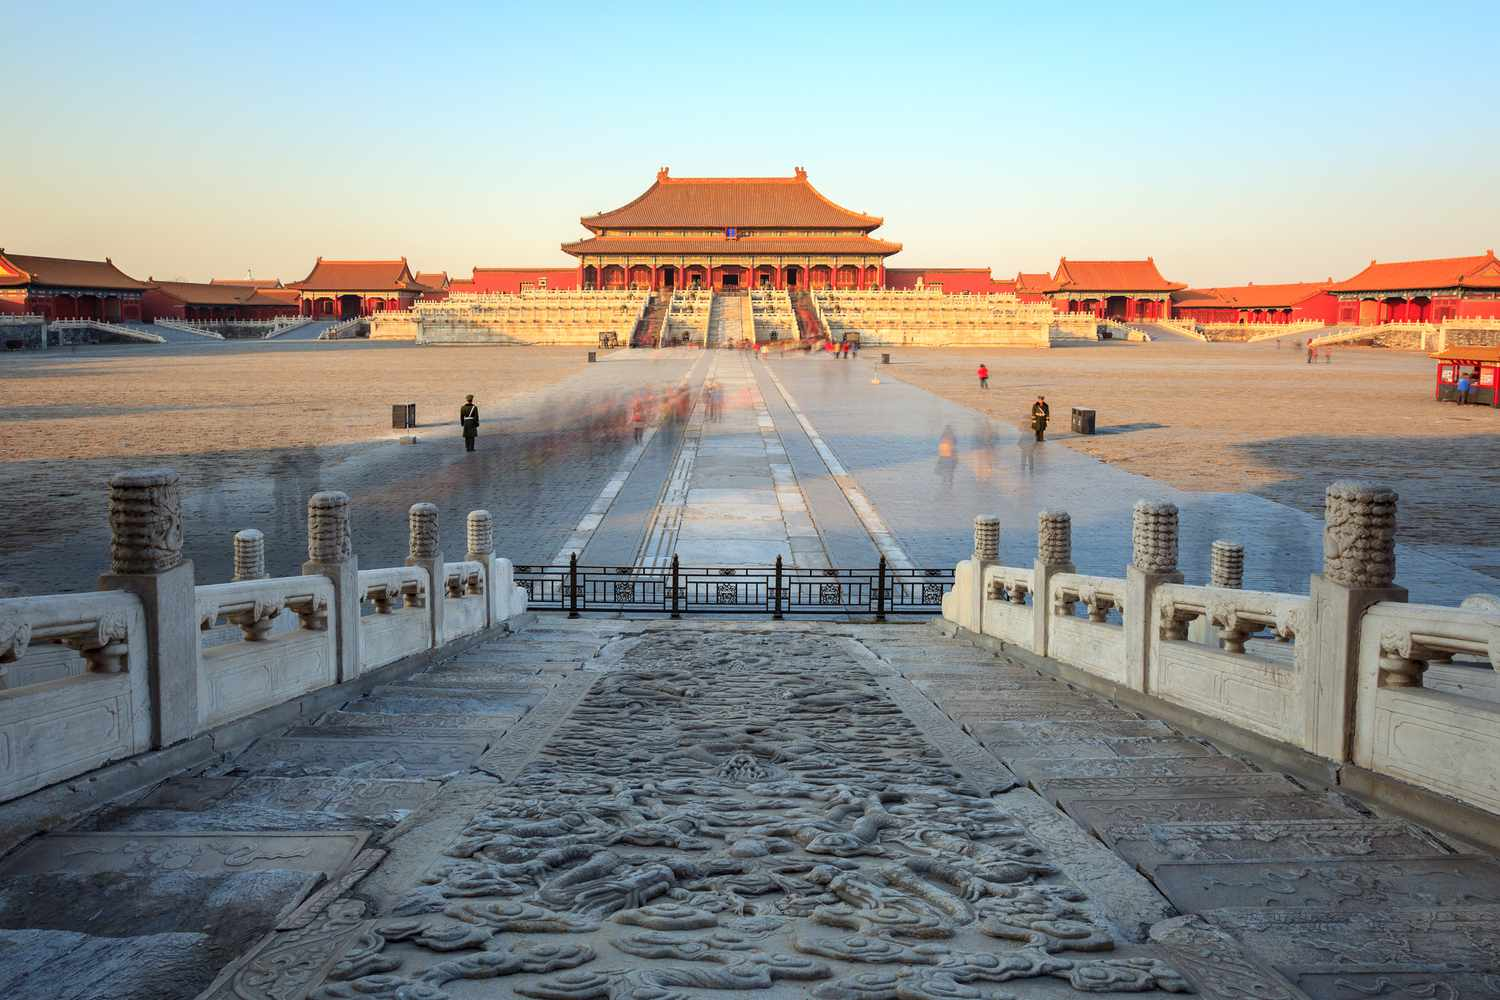Describe a peaceful evening at the Forbidden City. As the sun dips below the horizon, the Forbidden City is bathed in a warm, golden hue. The towering structures transition from glowing reds and yellows to softer, more muted tones. The courtyard, which earlier bustled with activity, is now serene; the only sounds are the distant echoes of footsteps and the rustling leaves in the mild evening breeze. Lanterns begin to flicker into life, casting their gentle light against the ancient walls. Guards maintain their silent vigil by the majestic stone lions, who seem less daunting in the gentle twilight. The faint aroma of incense wafts through the air, blending seamlessly with the cool, crisp fragrance of the night. The whole scene exudes tranquility, reflecting the majestic yet placid elegance of the Forbidden City at dusk. 